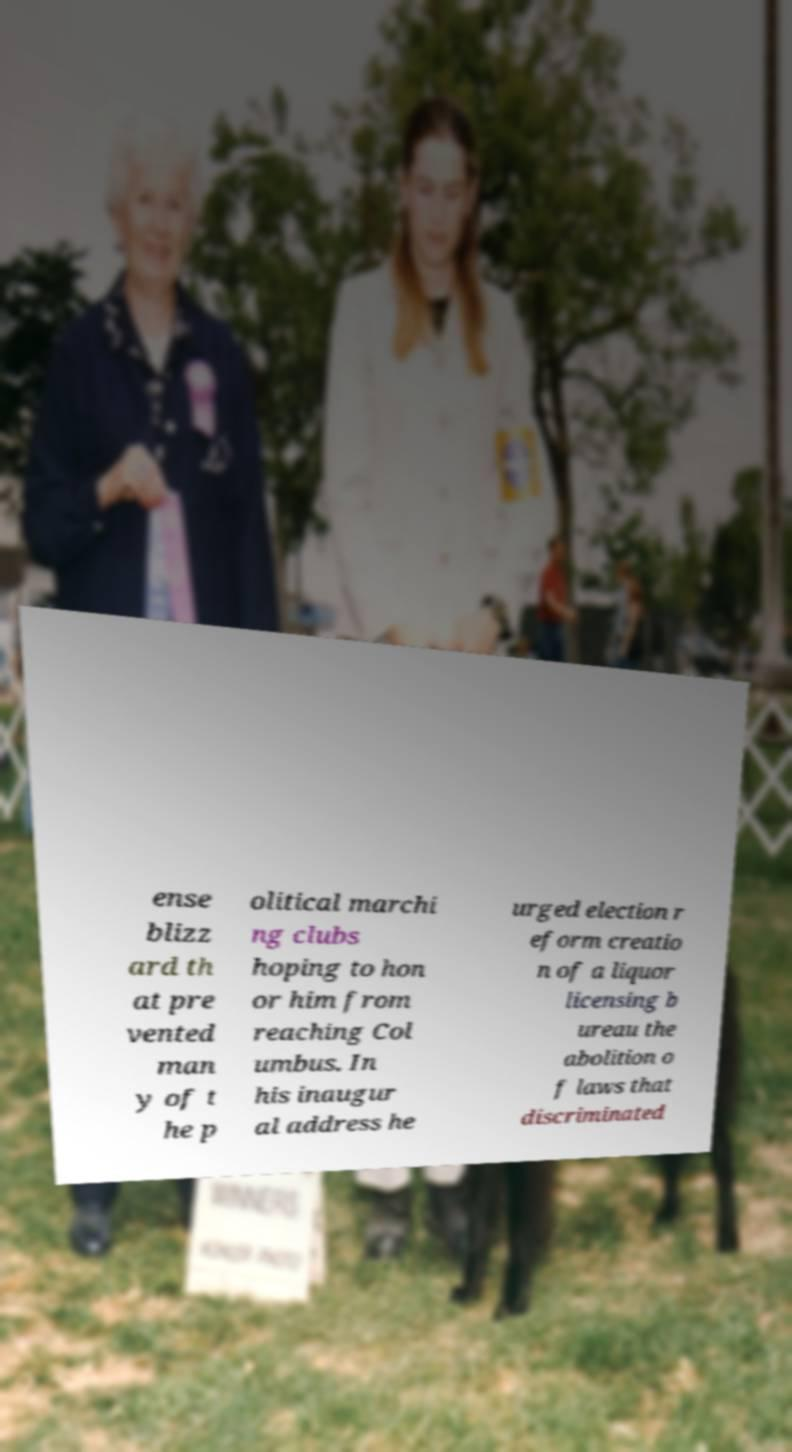What messages or text are displayed in this image? I need them in a readable, typed format. ense blizz ard th at pre vented man y of t he p olitical marchi ng clubs hoping to hon or him from reaching Col umbus. In his inaugur al address he urged election r eform creatio n of a liquor licensing b ureau the abolition o f laws that discriminated 